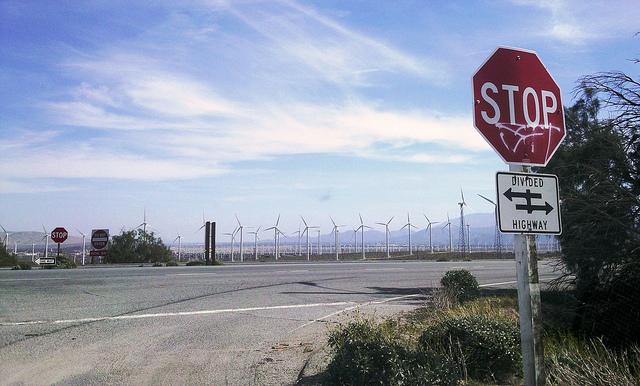What is being generated by the poles?
Be succinct. Electricity. Is this an industrial area?
Short answer required. Yes. Can you drive straight ahead from the stop sign?
Concise answer only. No. 